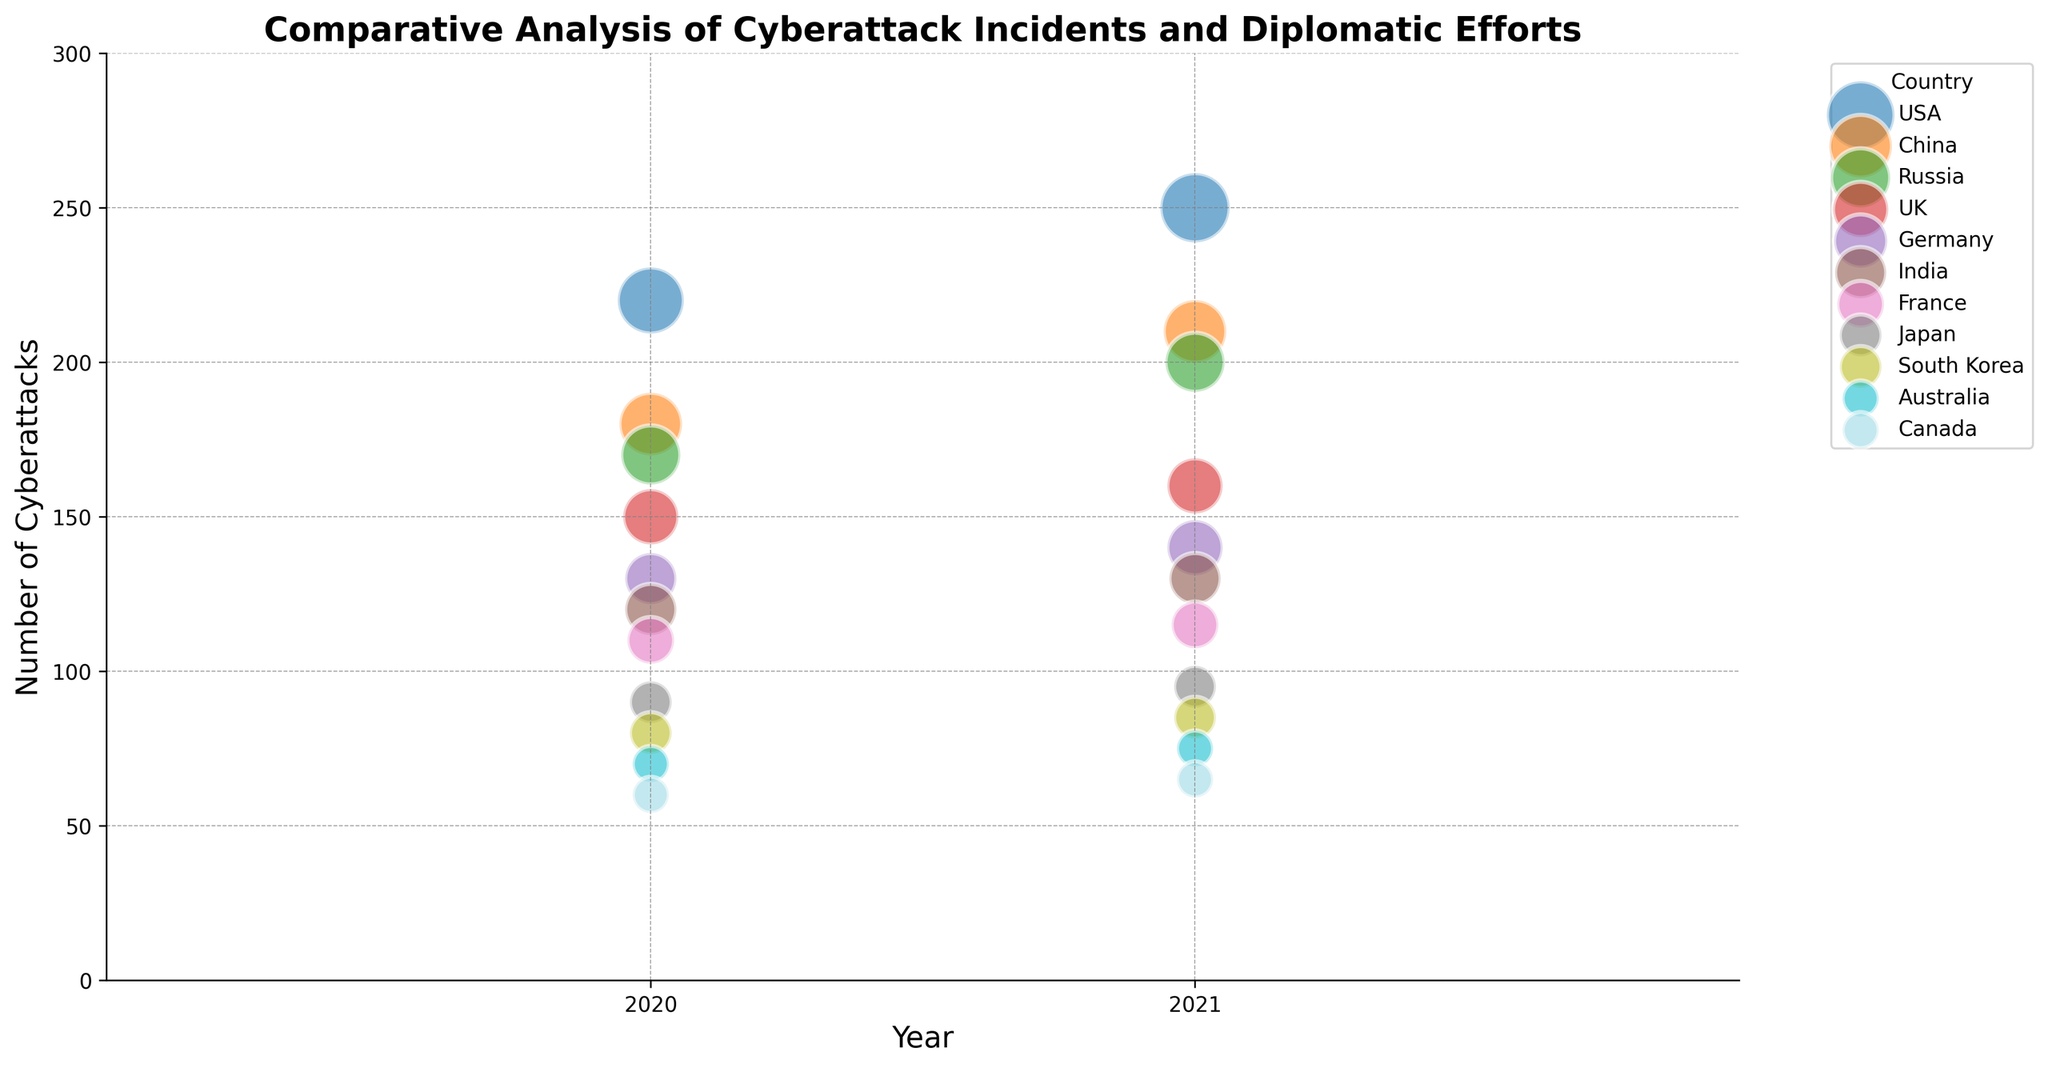Which country experienced the highest number of cyberattacks in 2021? From the plot, observe the data points along the 2021 year axis and compare the corresponding Number of Cyberattacks. The USA's bubble is positioned the highest, indicating it experienced the highest number of cyberattacks.
Answer: USA Which country had an increase in the number of cyberattacks but a decrease in the Diplomatic Efforts Score from 2020 to 2021? Compare bubbles of each country for the years 2020 and 2021. Both the number of cyberattacks and Diplomatic Efforts Score should be compared. The USA's bubble has an increase in the number of cyberattacks from 220 to 250, while the Diplomatic Efforts Score decreases from 8 to 7.
Answer: USA Which countries had a Diplomatic Efforts Score of 6 in 2021? Identify bubbles in the 2021 column and observe the Diplomatic Efforts Score. China, India, Japan, Canada have Diplomatic Efforts Scores of 6 in 2021.
Answer: China, India, Japan, Canada How did Germany's number of cyberattacks change from 2020 to 2021? Identify the bubbles for Germany in 2020 and 2021. Compare the position on the Number of Cyberattacks axis to see the change. Germany's number of cyberattacks increased from 130 to 140.
Answer: Increased Which country has the smallest bubble size, and what does it represent? Look at all the bubbles and identify the smallest one. The smallest bubbles belong to Australia and Canada, both with a Bubble Size of 3. Bubble size represents some underlying data metric such as the scale of incidents or significance.
Answer: Australia, Canada Compare the cyberattack incidents in the USA and China in 2020. Which country had more, and by what amount? Identify the bubbles for the USA and China in 2020, then compare their positions on the Number of Cyberattacks axis. The USA had 220 and China had 180. The difference is 220 - 180 = 40.
Answer: USA by 40 Which country had the highest Diplomatic Efforts Score in 2020 and how many cyberattacks did it experience that year? Observe the bubble with the highest position on the Diplomatic Efforts Score axis in 2020. Australia's bubble is at 8. Check its position on the Number of Cyberattacks axis, which is 70.
Answer: Australia, 70 Which year did the UK experience more cyberattacks? Compare the UK's bubbles between 2020 and 2021. Observe their positions on the Number of Cyberattacks axis. The UK experienced more cyberattacks in 2021 with 160 compared to 150 in 2020.
Answer: 2021 Which country with a Diplomatic Efforts Score of 7 in 2021 had the fewest cyberattacks, and what was the count? Identify all bubbles with a Diplomatic Efforts Score of 7 in 2021. Among these, find the one with the lowest position on the Number of Cyberattacks axis. France had the fewest with 115.
Answer: France, 115 